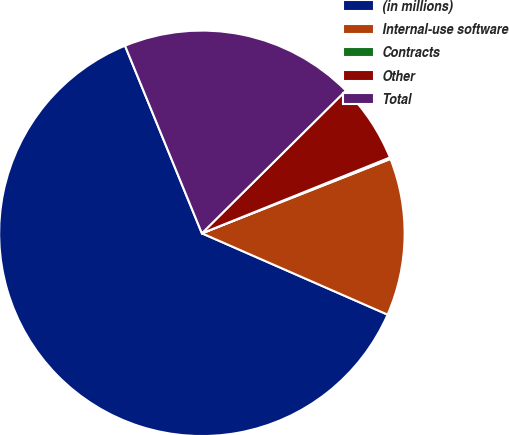Convert chart to OTSL. <chart><loc_0><loc_0><loc_500><loc_500><pie_chart><fcel>(in millions)<fcel>Internal-use software<fcel>Contracts<fcel>Other<fcel>Total<nl><fcel>62.24%<fcel>12.55%<fcel>0.12%<fcel>6.33%<fcel>18.76%<nl></chart> 